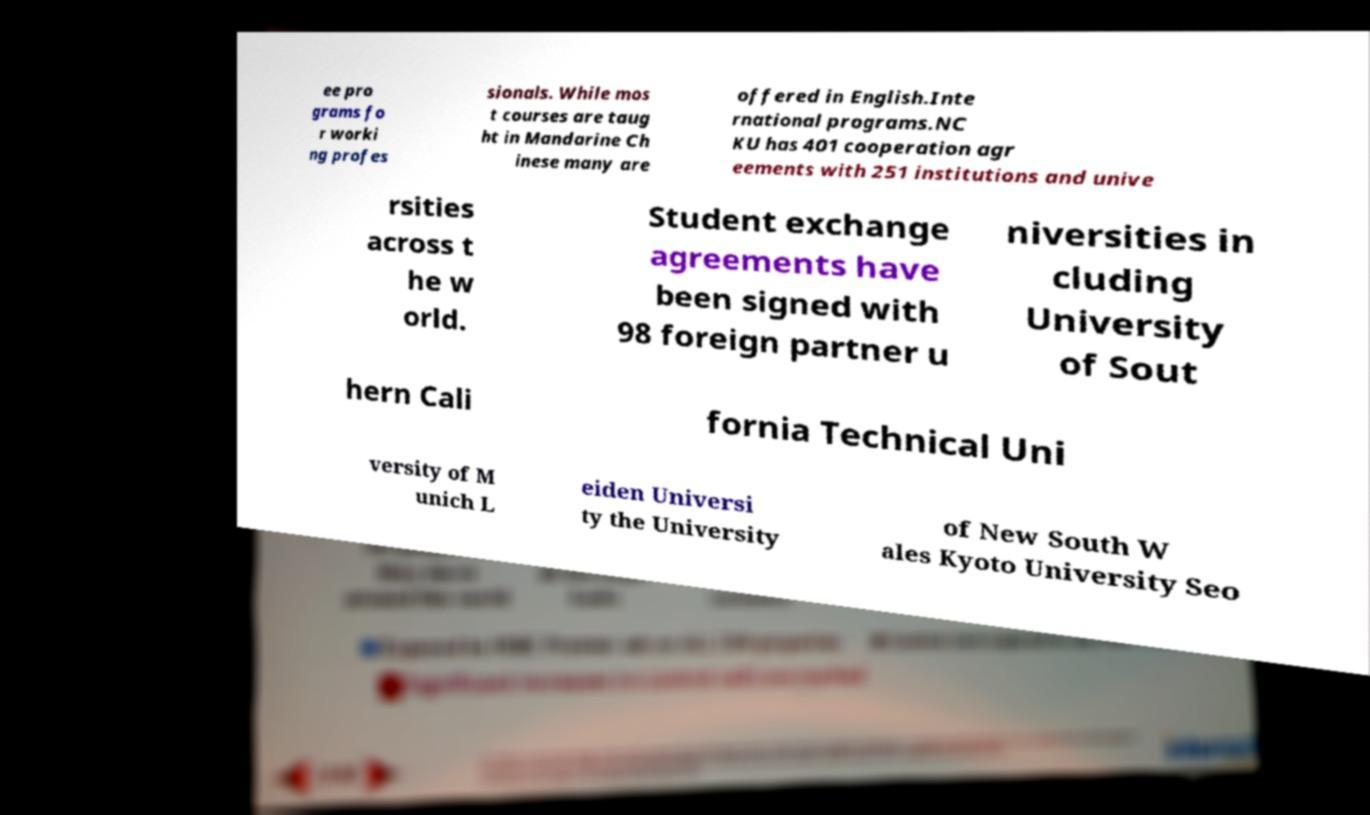Could you extract and type out the text from this image? ee pro grams fo r worki ng profes sionals. While mos t courses are taug ht in Mandarine Ch inese many are offered in English.Inte rnational programs.NC KU has 401 cooperation agr eements with 251 institutions and unive rsities across t he w orld. Student exchange agreements have been signed with 98 foreign partner u niversities in cluding University of Sout hern Cali fornia Technical Uni versity of M unich L eiden Universi ty the University of New South W ales Kyoto University Seo 